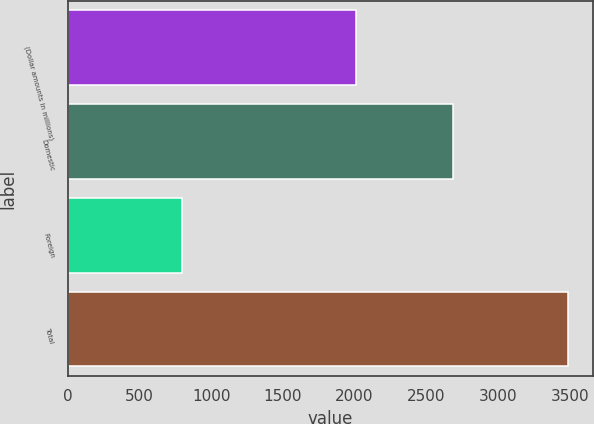Convert chart to OTSL. <chart><loc_0><loc_0><loc_500><loc_500><bar_chart><fcel>(Dollar amounts in millions)<fcel>Domestic<fcel>Foreign<fcel>Total<nl><fcel>2012<fcel>2690<fcel>798<fcel>3488<nl></chart> 